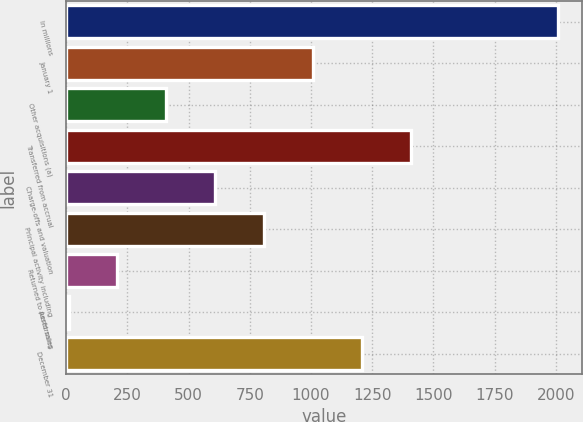Convert chart to OTSL. <chart><loc_0><loc_0><loc_500><loc_500><bar_chart><fcel>In millions<fcel>January 1<fcel>Other acquisitions (a)<fcel>Transferred from accrual<fcel>Charge-offs and valuation<fcel>Principal activity including<fcel>Returned to performing<fcel>Asset sales<fcel>December 31<nl><fcel>2007<fcel>1008.5<fcel>409.4<fcel>1407.9<fcel>609.1<fcel>808.8<fcel>209.7<fcel>10<fcel>1208.2<nl></chart> 